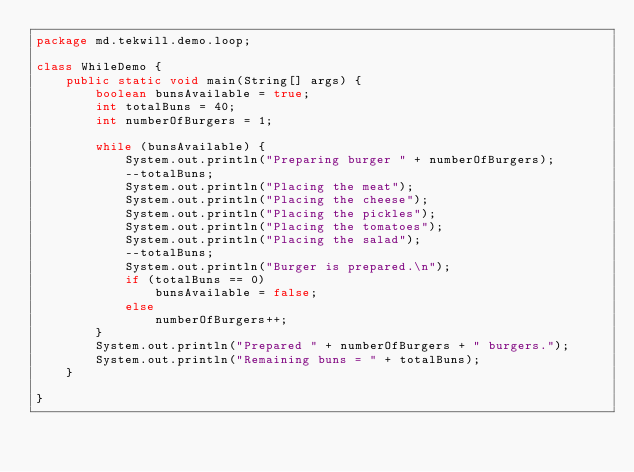<code> <loc_0><loc_0><loc_500><loc_500><_Java_>package md.tekwill.demo.loop;

class WhileDemo {
    public static void main(String[] args) {
        boolean bunsAvailable = true;
        int totalBuns = 40;
        int numberOfBurgers = 1;

        while (bunsAvailable) {
            System.out.println("Preparing burger " + numberOfBurgers);
            --totalBuns;
            System.out.println("Placing the meat");
            System.out.println("Placing the cheese");
            System.out.println("Placing the pickles");
            System.out.println("Placing the tomatoes");
            System.out.println("Placing the salad");
            --totalBuns;
            System.out.println("Burger is prepared.\n");
            if (totalBuns == 0)
                bunsAvailable = false;
            else
                numberOfBurgers++;
        }
        System.out.println("Prepared " + numberOfBurgers + " burgers.");
        System.out.println("Remaining buns = " + totalBuns);
    }

}
</code> 